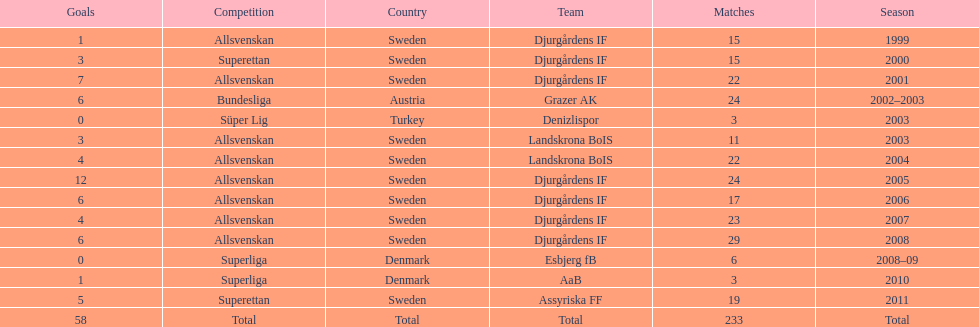Write the full table. {'header': ['Goals', 'Competition', 'Country', 'Team', 'Matches', 'Season'], 'rows': [['1', 'Allsvenskan', 'Sweden', 'Djurgårdens IF', '15', '1999'], ['3', 'Superettan', 'Sweden', 'Djurgårdens IF', '15', '2000'], ['7', 'Allsvenskan', 'Sweden', 'Djurgårdens IF', '22', '2001'], ['6', 'Bundesliga', 'Austria', 'Grazer AK', '24', '2002–2003'], ['0', 'Süper Lig', 'Turkey', 'Denizlispor', '3', '2003'], ['3', 'Allsvenskan', 'Sweden', 'Landskrona BoIS', '11', '2003'], ['4', 'Allsvenskan', 'Sweden', 'Landskrona BoIS', '22', '2004'], ['12', 'Allsvenskan', 'Sweden', 'Djurgårdens IF', '24', '2005'], ['6', 'Allsvenskan', 'Sweden', 'Djurgårdens IF', '17', '2006'], ['4', 'Allsvenskan', 'Sweden', 'Djurgårdens IF', '23', '2007'], ['6', 'Allsvenskan', 'Sweden', 'Djurgårdens IF', '29', '2008'], ['0', 'Superliga', 'Denmark', 'Esbjerg fB', '6', '2008–09'], ['1', 'Superliga', 'Denmark', 'AaB', '3', '2010'], ['5', 'Superettan', 'Sweden', 'Assyriska FF', '19', '2011'], ['58', 'Total', 'Total', 'Total', '233', 'Total']]} What is the total number of matches? 233. 